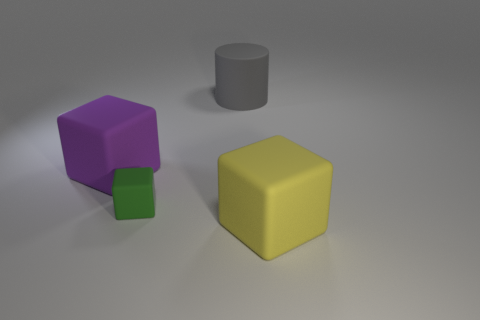Subtract all large blocks. How many blocks are left? 1 Add 4 brown matte balls. How many objects exist? 8 Subtract 0 blue cylinders. How many objects are left? 4 Subtract all cylinders. How many objects are left? 3 Subtract 1 cylinders. How many cylinders are left? 0 Subtract all brown cubes. Subtract all blue balls. How many cubes are left? 3 Subtract all brown cylinders. How many green blocks are left? 1 Subtract all rubber cylinders. Subtract all large purple rubber cubes. How many objects are left? 2 Add 4 large gray rubber things. How many large gray rubber things are left? 5 Add 2 tiny cyan blocks. How many tiny cyan blocks exist? 2 